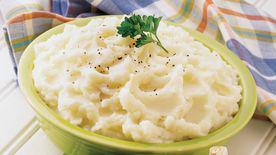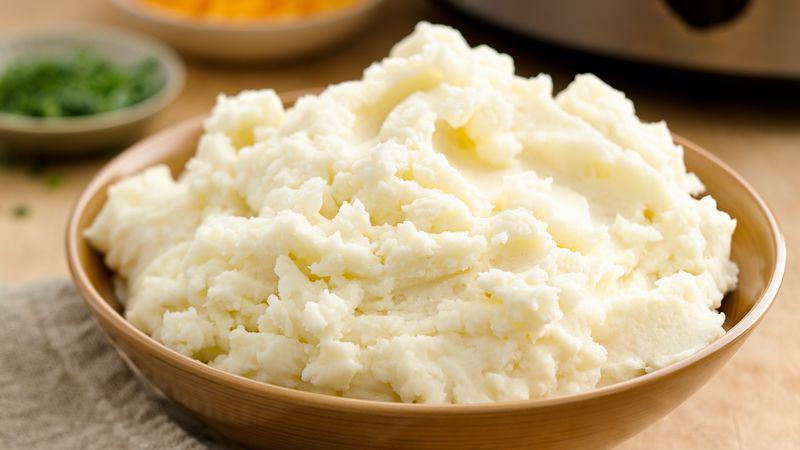The first image is the image on the left, the second image is the image on the right. Analyze the images presented: Is the assertion "One of the bowls is green" valid? Answer yes or no. Yes. 